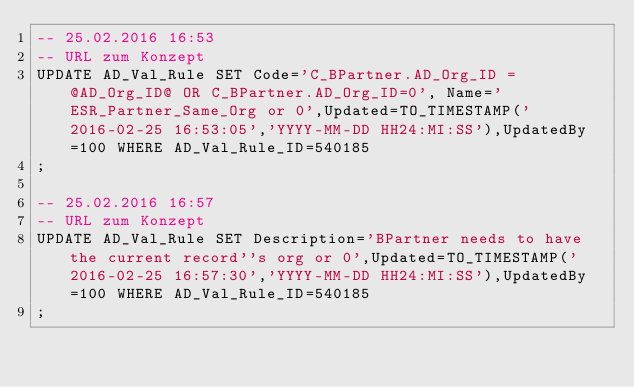Convert code to text. <code><loc_0><loc_0><loc_500><loc_500><_SQL_>-- 25.02.2016 16:53
-- URL zum Konzept
UPDATE AD_Val_Rule SET Code='C_BPartner.AD_Org_ID = @AD_Org_ID@ OR C_BPartner.AD_Org_ID=0', Name='ESR_Partner_Same_Org or 0',Updated=TO_TIMESTAMP('2016-02-25 16:53:05','YYYY-MM-DD HH24:MI:SS'),UpdatedBy=100 WHERE AD_Val_Rule_ID=540185
;

-- 25.02.2016 16:57
-- URL zum Konzept
UPDATE AD_Val_Rule SET Description='BPartner needs to have the current record''s org or 0',Updated=TO_TIMESTAMP('2016-02-25 16:57:30','YYYY-MM-DD HH24:MI:SS'),UpdatedBy=100 WHERE AD_Val_Rule_ID=540185
;

</code> 